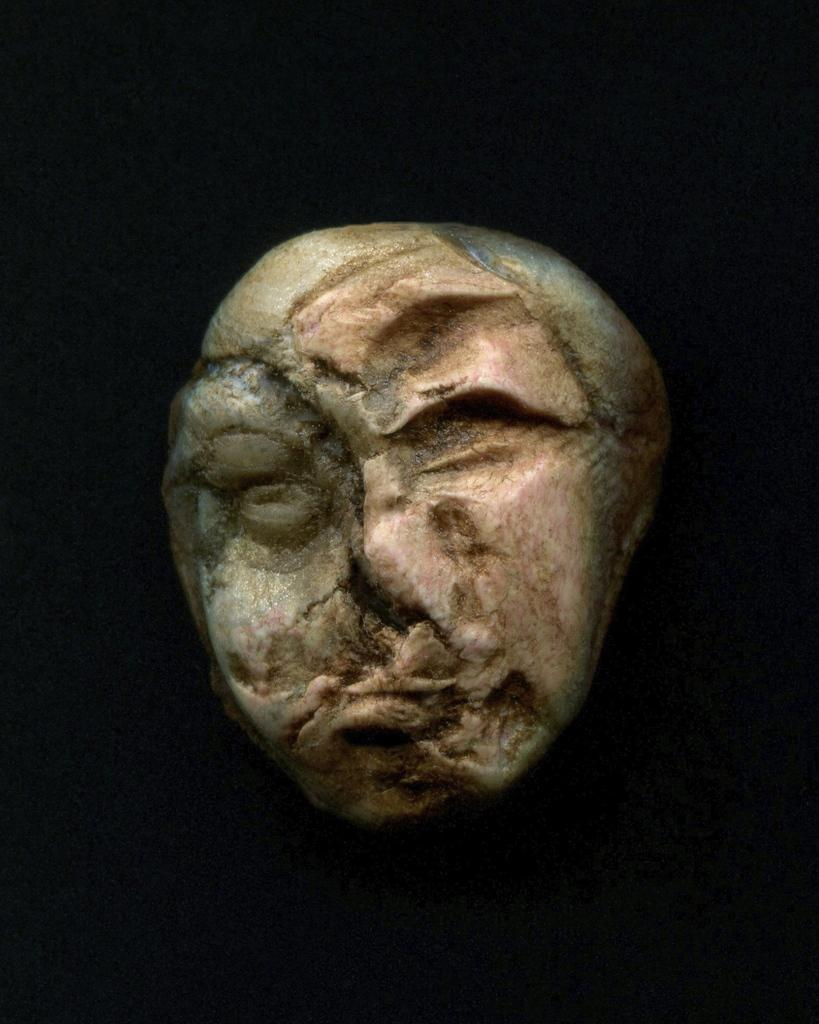What is the main subject of the image? There is a sculpture in the center of the image. Can you describe the background of the image? The background of the image is dark. How many boys are holding soda cans in the image? There are no boys or soda cans present in the image; it features a sculpture with a dark background. What color is the bead on the sculpture? There is no bead present on the sculpture in the image. 